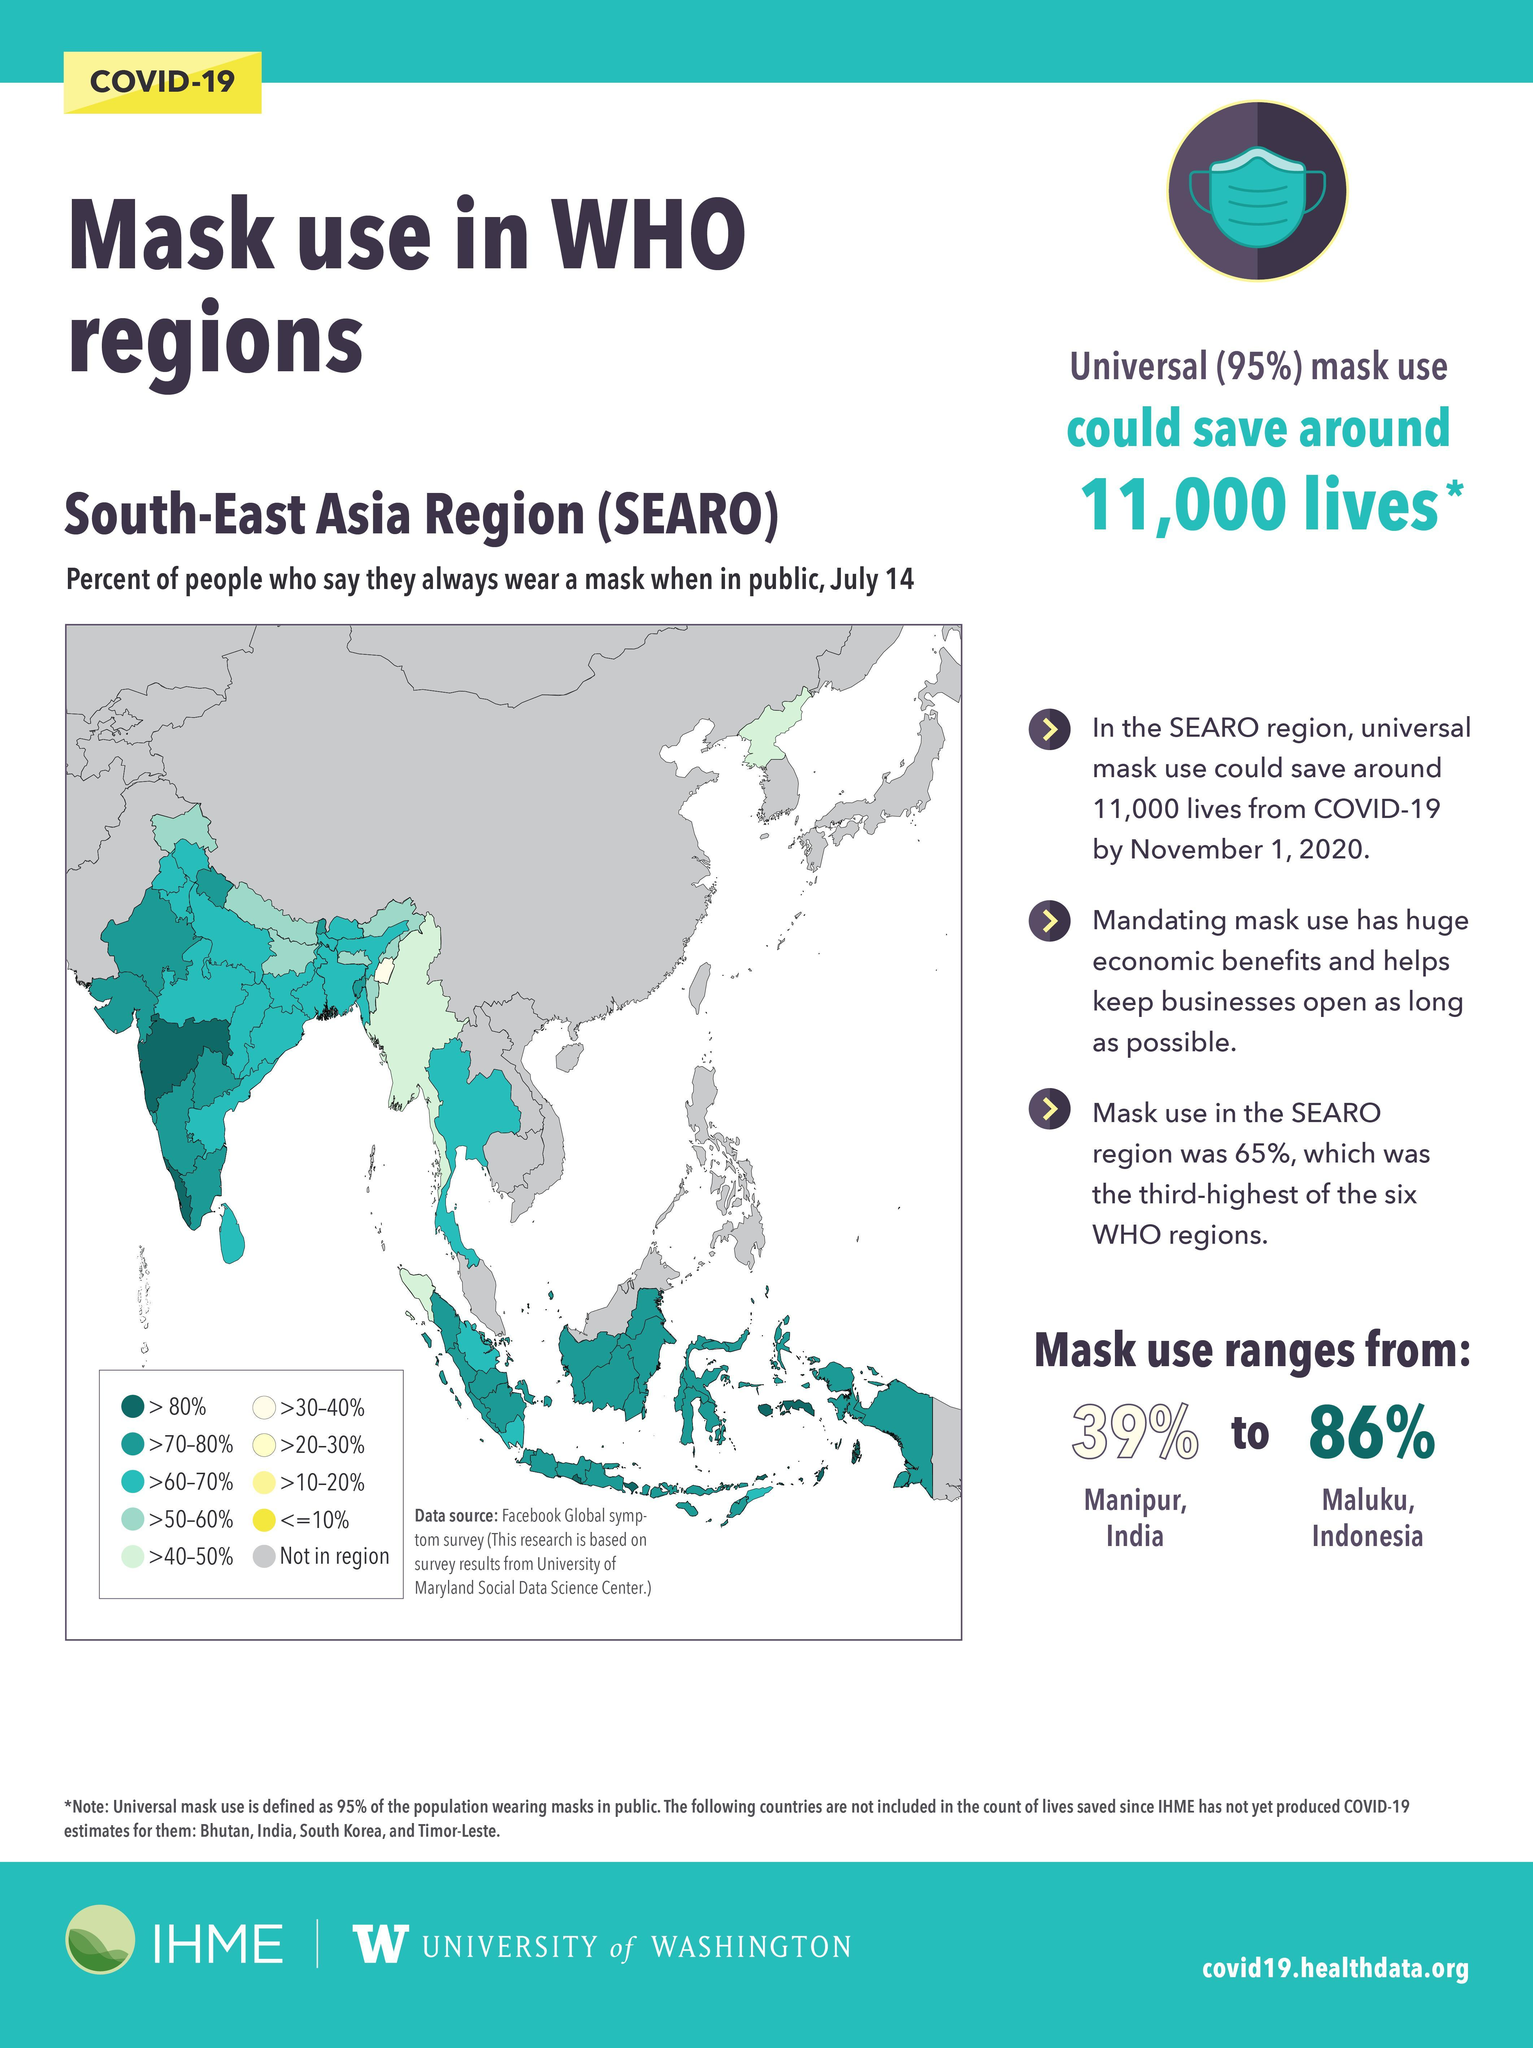Which region has the lowest percentage of mask usage?
Answer the question with a short phrase. Manipur, India Which country has the highest percentage of mask usage? Indonesia What is the inverse of universal mask usage? 5 How many countries have mask usage in the >40-50% range? 3 How much is the mask usage in Manipur? 39% What percentage of people use mask in the left-most island region? >60-70% How much is the mask usage in Maluku, Indonesia? 86% 